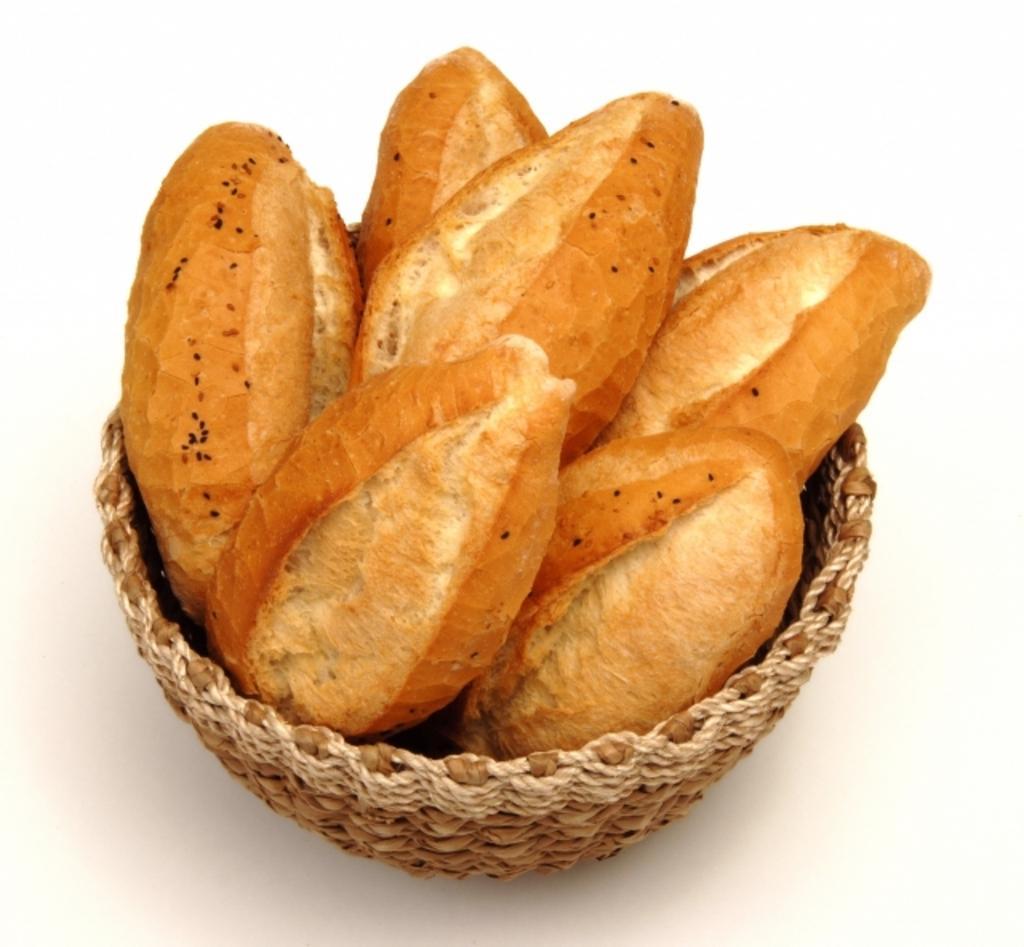Can you describe this image briefly? In this image there is a basket with a few buns in it. 